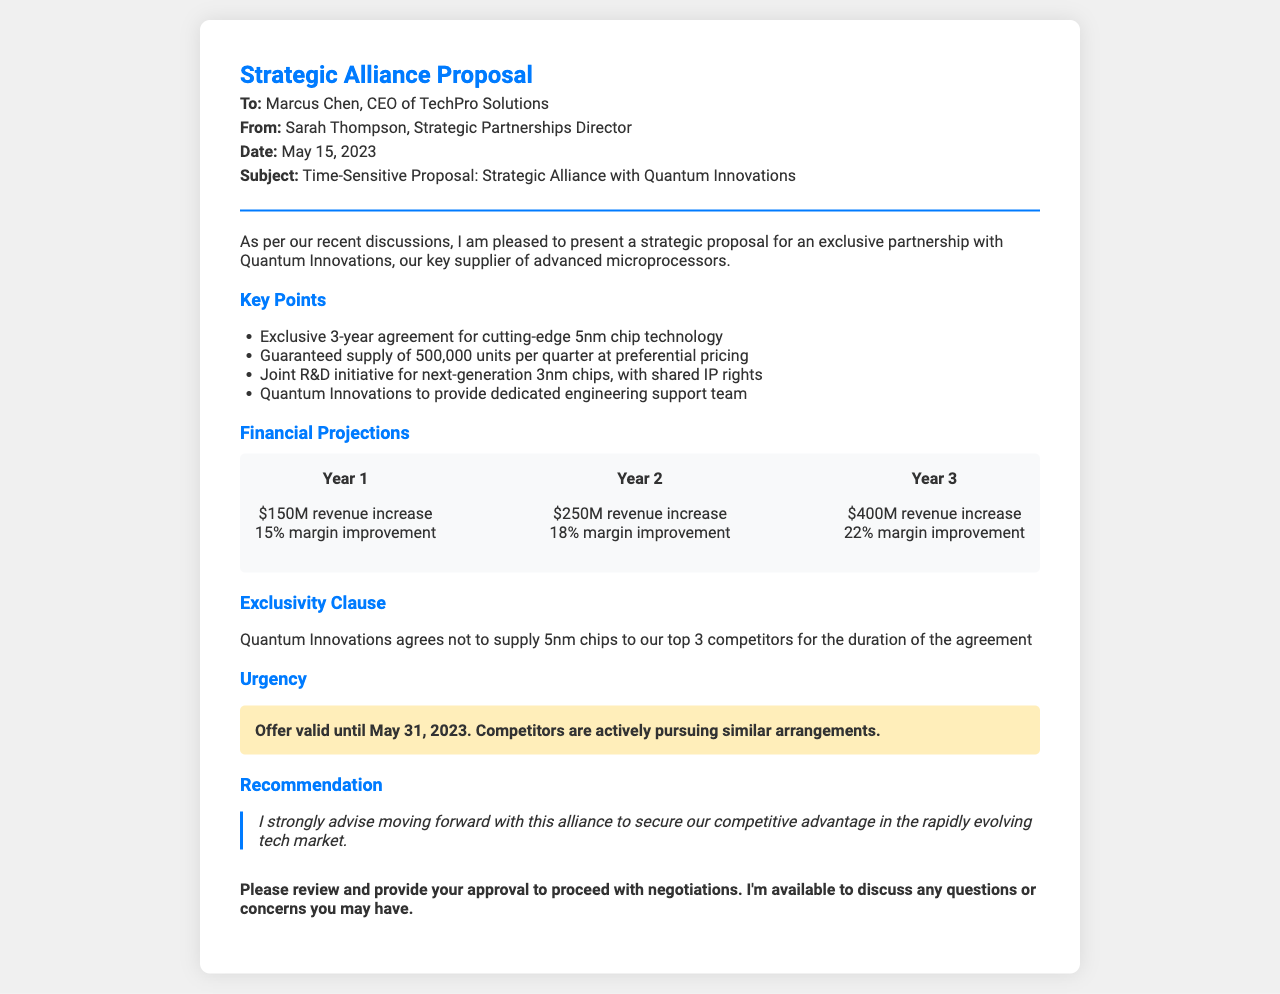what is the name of the key supplier? The document specifies that the key supplier is Quantum Innovations.
Answer: Quantum Innovations what is the duration of the exclusive agreement? The document states the agreement is for a 3-year term.
Answer: 3 years how many units are guaranteed per quarter? According to the document, the guaranteed supply is 500,000 units each quarter.
Answer: 500,000 units what is the projected revenue increase in Year 2? The document indicates a projected revenue increase of $250 million for Year 2.
Answer: $250M when is the offer valid until? The document mentions that the offer is valid until May 31, 2023.
Answer: May 31, 2023 how many competitors will not receive 5nm chips? The document specifies that Quantum Innovations will not supply 5nm chips to the top 3 competitors.
Answer: 3 competitors what is the margin improvement projected for Year 3? The document highlights a margin improvement of 22% for Year 3.
Answer: 22% what is the recommendation provided in the document? The document strongly advises to move forward with the alliance for a competitive advantage.
Answer: Move forward with this alliance 